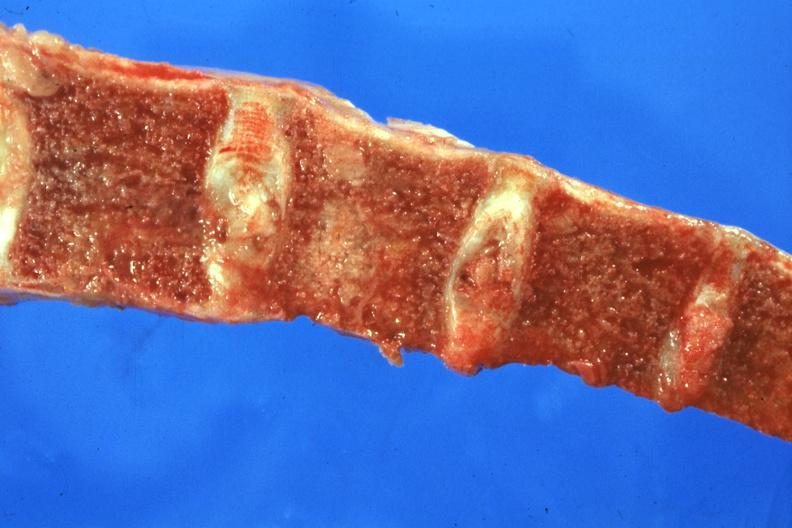what is present?
Answer the question using a single word or phrase. Joints 